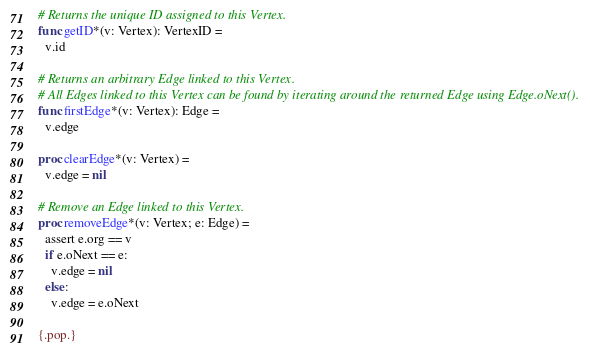Convert code to text. <code><loc_0><loc_0><loc_500><loc_500><_Nim_>
# Returns the unique ID assigned to this Vertex.
func getID*(v: Vertex): VertexID =
  v.id

# Returns an arbitrary Edge linked to this Vertex.
# All Edges linked to this Vertex can be found by iterating around the returned Edge using Edge.oNext().
func firstEdge*(v: Vertex): Edge =
  v.edge

proc clearEdge*(v: Vertex) =
  v.edge = nil

# Remove an Edge linked to this Vertex.
proc removeEdge*(v: Vertex; e: Edge) =
  assert e.org == v
  if e.oNext == e:
    v.edge = nil
  else:
    v.edge = e.oNext

{.pop.}
</code> 